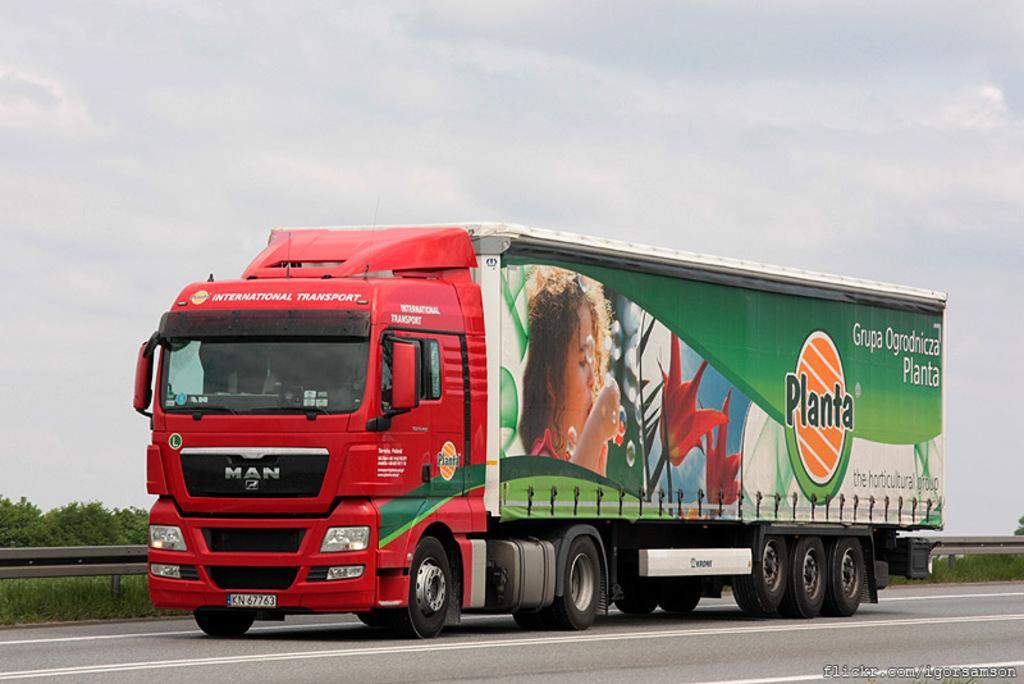Please provide a concise description of this image. In this image I can see a red color truck on the road which is facing towards the left side. Inside the truck there is a person sitting. Behind the vehicle I can see the railing, grass and trees. At the top of the image I can see the sky. 